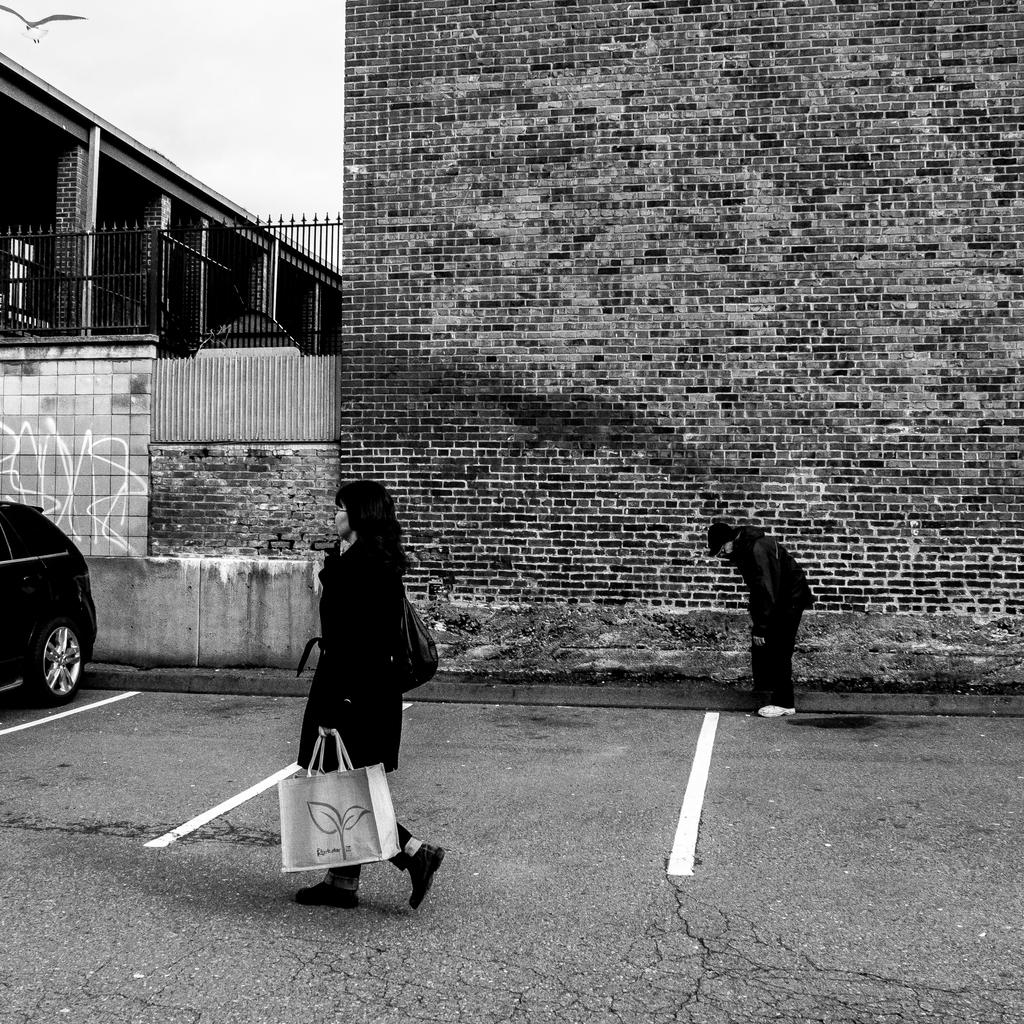What is the woman in the image doing? The woman is walking on the street. What can be seen on the right side of the image? There is a brick wall on the right side of the image. What is located on the left side of the image? There is a vehicle parked on the left side of the image. How many hands does the jellyfish have in the image? There is no jellyfish present in the image. What type of yoke is visible in the image? There is no yoke present in the image. 